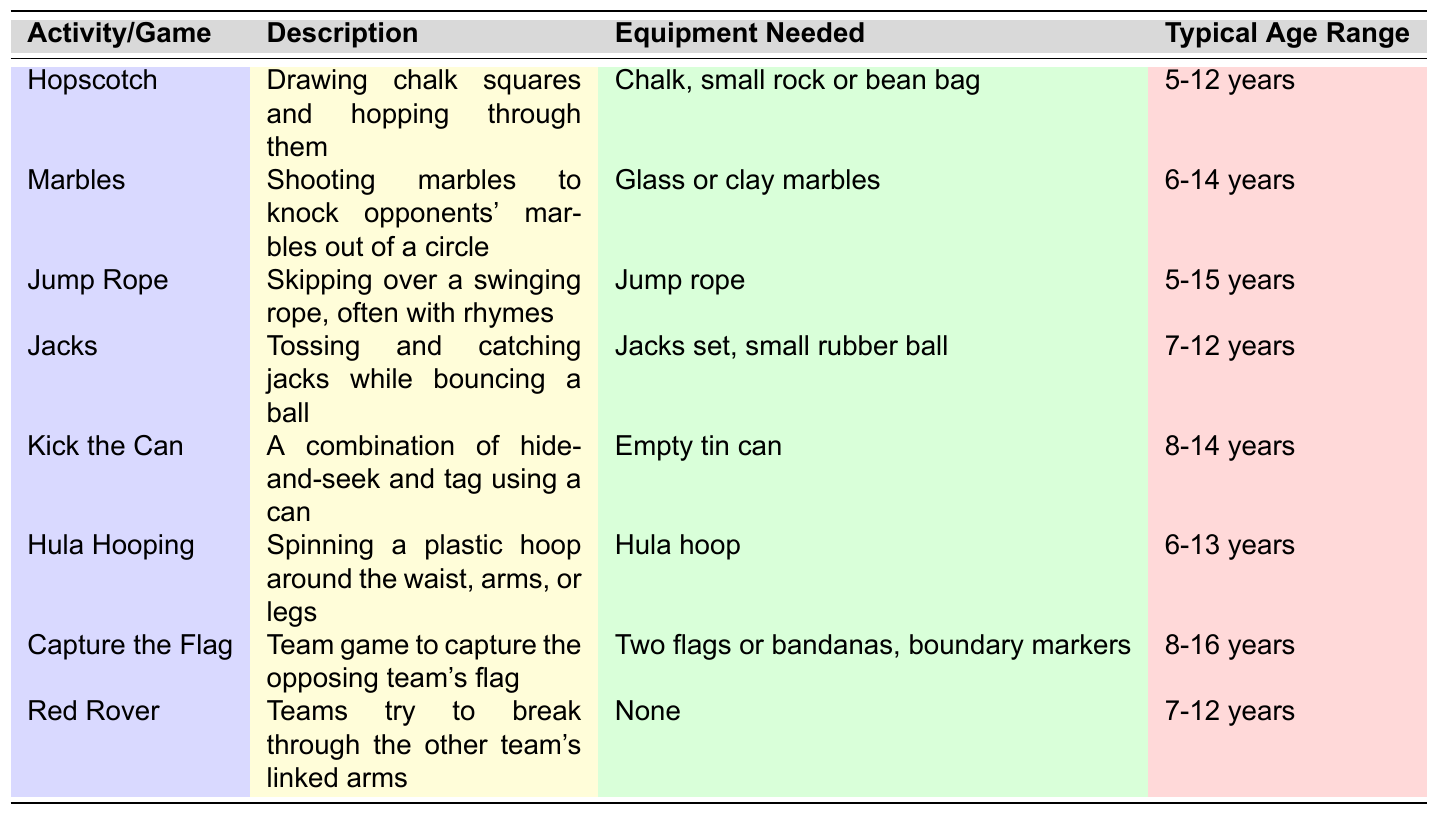What is the typical age range for playing "Marbles"? The table shows that the typical age range for "Marbles" is listed as "6-14 years".
Answer: 6-14 years How many activities/games have a typical age range of 8 years or older? The activities "Kick the Can", "Capture the Flag", and "Red Rover" have age ranges starting from 8 years or older. Counting these gives a total of 3 activities.
Answer: 3 Is "Hula Hooping" played with any equipment? According to the table, "Hula Hooping" requires a "Hula hoop," indicating that equipment is needed.
Answer: Yes What are the activities that can be played by children aged 5 years? The table indicates that "Hopscotch" and "Jump Rope" are activities that can be played by children aged 5 years.
Answer: Hopscotch, Jump Rope Which activity has no equipment needed, and what is its typical age range? The table states that "Red Rover" requires no equipment, and its typical age range is "7-12 years".
Answer: Red Rover, 7-12 years Are the typical age ranges for "Kick the Can" and "Capture the Flag" overlapping? The typical age range for "Kick the Can" is "8-14 years", and for "Capture the Flag", it is "8-16 years". Both age ranges start at 8 years; hence they overlap.
Answer: Yes, they overlap How many activities can be played by children aged 6 years? The activities "Marbles", "Jump Rope", "Hula Hooping" can be played by children aged 6 years, which is a total of 3 activities.
Answer: 3 What is the oldest age range for any of the activities listed? The oldest age range listed is for "Capture the Flag", which extends to "16 years".
Answer: 16 years If a child is 15 years old, which activities can they participate in based on the table? The activities "Jump Rope", "Kick the Can", "Hula Hooping", and "Capture the Flag" are available for someone who is 15 years old or younger, so they can participate in all four.
Answer: Jump Rope, Kick the Can, Hula Hooping, Capture the Flag What two activities require specific equipment, and what is that equipment? "Marbles" requires "Glass or clay marbles," and "Jacks" requires a "Jacks set, small rubber ball."
Answer: Marbles: Glass or clay marbles, Jacks: Jacks set, small rubber ball 